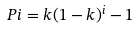<formula> <loc_0><loc_0><loc_500><loc_500>P i = k ( 1 - k ) ^ { i } - 1</formula> 